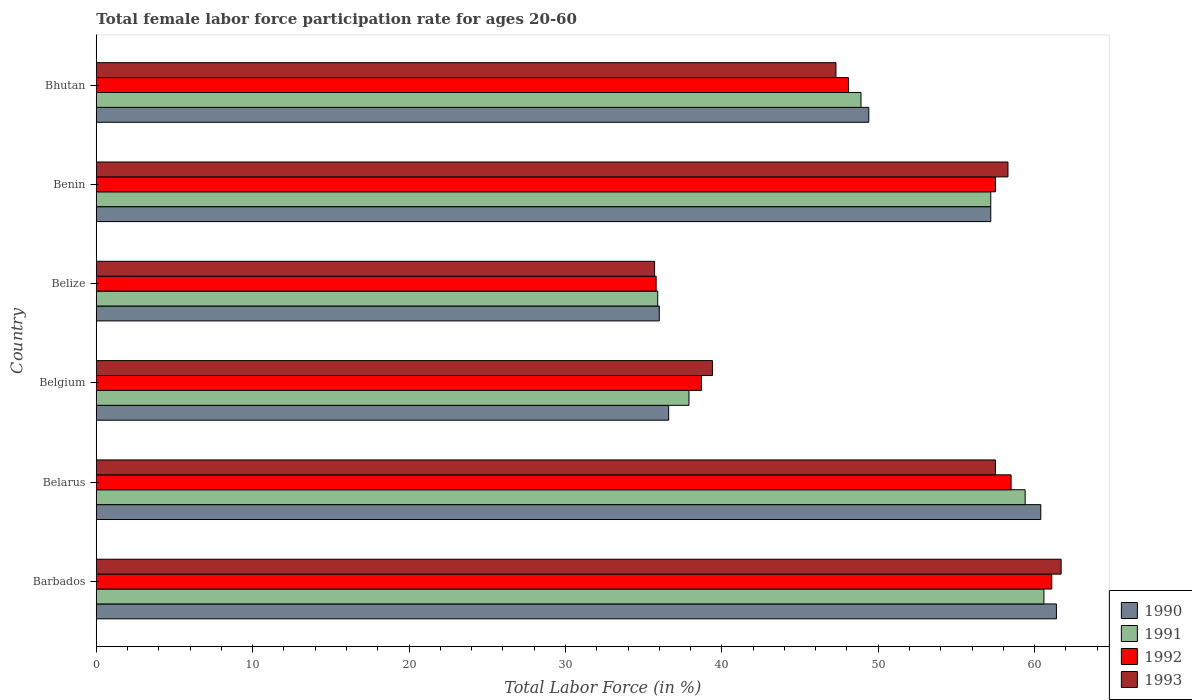How many groups of bars are there?
Keep it short and to the point. 6. Are the number of bars per tick equal to the number of legend labels?
Your answer should be very brief. Yes. Are the number of bars on each tick of the Y-axis equal?
Give a very brief answer. Yes. What is the female labor force participation rate in 1991 in Belarus?
Provide a succinct answer. 59.4. Across all countries, what is the maximum female labor force participation rate in 1992?
Provide a succinct answer. 61.1. Across all countries, what is the minimum female labor force participation rate in 1992?
Offer a terse response. 35.8. In which country was the female labor force participation rate in 1991 maximum?
Your answer should be compact. Barbados. In which country was the female labor force participation rate in 1993 minimum?
Your response must be concise. Belize. What is the total female labor force participation rate in 1991 in the graph?
Make the answer very short. 299.9. What is the difference between the female labor force participation rate in 1991 in Belgium and that in Belize?
Your answer should be very brief. 2. What is the difference between the female labor force participation rate in 1990 in Bhutan and the female labor force participation rate in 1991 in Barbados?
Make the answer very short. -11.2. What is the average female labor force participation rate in 1992 per country?
Provide a succinct answer. 49.95. What is the difference between the female labor force participation rate in 1992 and female labor force participation rate in 1991 in Benin?
Provide a succinct answer. 0.3. In how many countries, is the female labor force participation rate in 1990 greater than 56 %?
Ensure brevity in your answer.  3. What is the ratio of the female labor force participation rate in 1991 in Barbados to that in Belgium?
Your response must be concise. 1.6. Is the female labor force participation rate in 1991 in Barbados less than that in Belize?
Offer a terse response. No. Is the difference between the female labor force participation rate in 1992 in Belize and Bhutan greater than the difference between the female labor force participation rate in 1991 in Belize and Bhutan?
Ensure brevity in your answer.  Yes. What is the difference between the highest and the second highest female labor force participation rate in 1991?
Keep it short and to the point. 1.2. What is the difference between the highest and the lowest female labor force participation rate in 1993?
Offer a terse response. 26. Is the sum of the female labor force participation rate in 1992 in Belize and Benin greater than the maximum female labor force participation rate in 1990 across all countries?
Offer a terse response. Yes. Is it the case that in every country, the sum of the female labor force participation rate in 1991 and female labor force participation rate in 1992 is greater than the sum of female labor force participation rate in 1990 and female labor force participation rate in 1993?
Give a very brief answer. No. What does the 3rd bar from the bottom in Belgium represents?
Offer a terse response. 1992. Are the values on the major ticks of X-axis written in scientific E-notation?
Ensure brevity in your answer.  No. Where does the legend appear in the graph?
Provide a succinct answer. Bottom right. How many legend labels are there?
Keep it short and to the point. 4. How are the legend labels stacked?
Offer a terse response. Vertical. What is the title of the graph?
Ensure brevity in your answer.  Total female labor force participation rate for ages 20-60. Does "1965" appear as one of the legend labels in the graph?
Make the answer very short. No. What is the label or title of the Y-axis?
Offer a terse response. Country. What is the Total Labor Force (in %) in 1990 in Barbados?
Your answer should be compact. 61.4. What is the Total Labor Force (in %) of 1991 in Barbados?
Provide a succinct answer. 60.6. What is the Total Labor Force (in %) in 1992 in Barbados?
Keep it short and to the point. 61.1. What is the Total Labor Force (in %) of 1993 in Barbados?
Give a very brief answer. 61.7. What is the Total Labor Force (in %) in 1990 in Belarus?
Provide a succinct answer. 60.4. What is the Total Labor Force (in %) in 1991 in Belarus?
Your answer should be compact. 59.4. What is the Total Labor Force (in %) of 1992 in Belarus?
Keep it short and to the point. 58.5. What is the Total Labor Force (in %) of 1993 in Belarus?
Give a very brief answer. 57.5. What is the Total Labor Force (in %) in 1990 in Belgium?
Give a very brief answer. 36.6. What is the Total Labor Force (in %) in 1991 in Belgium?
Keep it short and to the point. 37.9. What is the Total Labor Force (in %) in 1992 in Belgium?
Make the answer very short. 38.7. What is the Total Labor Force (in %) in 1993 in Belgium?
Ensure brevity in your answer.  39.4. What is the Total Labor Force (in %) in 1991 in Belize?
Give a very brief answer. 35.9. What is the Total Labor Force (in %) in 1992 in Belize?
Make the answer very short. 35.8. What is the Total Labor Force (in %) in 1993 in Belize?
Offer a terse response. 35.7. What is the Total Labor Force (in %) in 1990 in Benin?
Offer a very short reply. 57.2. What is the Total Labor Force (in %) in 1991 in Benin?
Your answer should be very brief. 57.2. What is the Total Labor Force (in %) in 1992 in Benin?
Keep it short and to the point. 57.5. What is the Total Labor Force (in %) in 1993 in Benin?
Provide a succinct answer. 58.3. What is the Total Labor Force (in %) in 1990 in Bhutan?
Provide a succinct answer. 49.4. What is the Total Labor Force (in %) in 1991 in Bhutan?
Ensure brevity in your answer.  48.9. What is the Total Labor Force (in %) in 1992 in Bhutan?
Your response must be concise. 48.1. What is the Total Labor Force (in %) in 1993 in Bhutan?
Keep it short and to the point. 47.3. Across all countries, what is the maximum Total Labor Force (in %) in 1990?
Make the answer very short. 61.4. Across all countries, what is the maximum Total Labor Force (in %) of 1991?
Ensure brevity in your answer.  60.6. Across all countries, what is the maximum Total Labor Force (in %) of 1992?
Your response must be concise. 61.1. Across all countries, what is the maximum Total Labor Force (in %) in 1993?
Keep it short and to the point. 61.7. Across all countries, what is the minimum Total Labor Force (in %) of 1990?
Give a very brief answer. 36. Across all countries, what is the minimum Total Labor Force (in %) of 1991?
Give a very brief answer. 35.9. Across all countries, what is the minimum Total Labor Force (in %) of 1992?
Keep it short and to the point. 35.8. Across all countries, what is the minimum Total Labor Force (in %) in 1993?
Your answer should be compact. 35.7. What is the total Total Labor Force (in %) of 1990 in the graph?
Offer a very short reply. 301. What is the total Total Labor Force (in %) in 1991 in the graph?
Your answer should be compact. 299.9. What is the total Total Labor Force (in %) of 1992 in the graph?
Keep it short and to the point. 299.7. What is the total Total Labor Force (in %) of 1993 in the graph?
Give a very brief answer. 299.9. What is the difference between the Total Labor Force (in %) of 1990 in Barbados and that in Belarus?
Make the answer very short. 1. What is the difference between the Total Labor Force (in %) of 1992 in Barbados and that in Belarus?
Make the answer very short. 2.6. What is the difference between the Total Labor Force (in %) in 1990 in Barbados and that in Belgium?
Your answer should be compact. 24.8. What is the difference between the Total Labor Force (in %) of 1991 in Barbados and that in Belgium?
Keep it short and to the point. 22.7. What is the difference between the Total Labor Force (in %) in 1992 in Barbados and that in Belgium?
Offer a terse response. 22.4. What is the difference between the Total Labor Force (in %) of 1993 in Barbados and that in Belgium?
Keep it short and to the point. 22.3. What is the difference between the Total Labor Force (in %) of 1990 in Barbados and that in Belize?
Keep it short and to the point. 25.4. What is the difference between the Total Labor Force (in %) in 1991 in Barbados and that in Belize?
Provide a succinct answer. 24.7. What is the difference between the Total Labor Force (in %) of 1992 in Barbados and that in Belize?
Give a very brief answer. 25.3. What is the difference between the Total Labor Force (in %) of 1990 in Barbados and that in Benin?
Your answer should be very brief. 4.2. What is the difference between the Total Labor Force (in %) in 1991 in Barbados and that in Benin?
Your answer should be compact. 3.4. What is the difference between the Total Labor Force (in %) in 1992 in Barbados and that in Benin?
Ensure brevity in your answer.  3.6. What is the difference between the Total Labor Force (in %) of 1993 in Barbados and that in Benin?
Your answer should be compact. 3.4. What is the difference between the Total Labor Force (in %) of 1990 in Barbados and that in Bhutan?
Your answer should be very brief. 12. What is the difference between the Total Labor Force (in %) of 1991 in Barbados and that in Bhutan?
Your answer should be very brief. 11.7. What is the difference between the Total Labor Force (in %) in 1993 in Barbados and that in Bhutan?
Offer a very short reply. 14.4. What is the difference between the Total Labor Force (in %) in 1990 in Belarus and that in Belgium?
Your answer should be very brief. 23.8. What is the difference between the Total Labor Force (in %) in 1991 in Belarus and that in Belgium?
Keep it short and to the point. 21.5. What is the difference between the Total Labor Force (in %) in 1992 in Belarus and that in Belgium?
Your response must be concise. 19.8. What is the difference between the Total Labor Force (in %) in 1993 in Belarus and that in Belgium?
Make the answer very short. 18.1. What is the difference between the Total Labor Force (in %) in 1990 in Belarus and that in Belize?
Your answer should be very brief. 24.4. What is the difference between the Total Labor Force (in %) of 1992 in Belarus and that in Belize?
Make the answer very short. 22.7. What is the difference between the Total Labor Force (in %) in 1993 in Belarus and that in Belize?
Your response must be concise. 21.8. What is the difference between the Total Labor Force (in %) of 1990 in Belarus and that in Benin?
Your answer should be very brief. 3.2. What is the difference between the Total Labor Force (in %) of 1991 in Belarus and that in Benin?
Provide a succinct answer. 2.2. What is the difference between the Total Labor Force (in %) in 1992 in Belarus and that in Benin?
Make the answer very short. 1. What is the difference between the Total Labor Force (in %) in 1990 in Belarus and that in Bhutan?
Provide a short and direct response. 11. What is the difference between the Total Labor Force (in %) in 1991 in Belarus and that in Bhutan?
Give a very brief answer. 10.5. What is the difference between the Total Labor Force (in %) in 1992 in Belarus and that in Bhutan?
Offer a very short reply. 10.4. What is the difference between the Total Labor Force (in %) of 1992 in Belgium and that in Belize?
Ensure brevity in your answer.  2.9. What is the difference between the Total Labor Force (in %) of 1993 in Belgium and that in Belize?
Provide a short and direct response. 3.7. What is the difference between the Total Labor Force (in %) in 1990 in Belgium and that in Benin?
Keep it short and to the point. -20.6. What is the difference between the Total Labor Force (in %) of 1991 in Belgium and that in Benin?
Provide a short and direct response. -19.3. What is the difference between the Total Labor Force (in %) in 1992 in Belgium and that in Benin?
Offer a terse response. -18.8. What is the difference between the Total Labor Force (in %) of 1993 in Belgium and that in Benin?
Your answer should be compact. -18.9. What is the difference between the Total Labor Force (in %) in 1992 in Belgium and that in Bhutan?
Ensure brevity in your answer.  -9.4. What is the difference between the Total Labor Force (in %) of 1990 in Belize and that in Benin?
Your response must be concise. -21.2. What is the difference between the Total Labor Force (in %) in 1991 in Belize and that in Benin?
Your answer should be compact. -21.3. What is the difference between the Total Labor Force (in %) in 1992 in Belize and that in Benin?
Your response must be concise. -21.7. What is the difference between the Total Labor Force (in %) of 1993 in Belize and that in Benin?
Your answer should be very brief. -22.6. What is the difference between the Total Labor Force (in %) of 1991 in Belize and that in Bhutan?
Your answer should be compact. -13. What is the difference between the Total Labor Force (in %) in 1992 in Belize and that in Bhutan?
Your answer should be very brief. -12.3. What is the difference between the Total Labor Force (in %) of 1990 in Barbados and the Total Labor Force (in %) of 1991 in Belarus?
Your answer should be compact. 2. What is the difference between the Total Labor Force (in %) of 1990 in Barbados and the Total Labor Force (in %) of 1992 in Belarus?
Provide a short and direct response. 2.9. What is the difference between the Total Labor Force (in %) in 1992 in Barbados and the Total Labor Force (in %) in 1993 in Belarus?
Keep it short and to the point. 3.6. What is the difference between the Total Labor Force (in %) of 1990 in Barbados and the Total Labor Force (in %) of 1991 in Belgium?
Offer a terse response. 23.5. What is the difference between the Total Labor Force (in %) of 1990 in Barbados and the Total Labor Force (in %) of 1992 in Belgium?
Make the answer very short. 22.7. What is the difference between the Total Labor Force (in %) of 1991 in Barbados and the Total Labor Force (in %) of 1992 in Belgium?
Provide a succinct answer. 21.9. What is the difference between the Total Labor Force (in %) of 1991 in Barbados and the Total Labor Force (in %) of 1993 in Belgium?
Ensure brevity in your answer.  21.2. What is the difference between the Total Labor Force (in %) of 1992 in Barbados and the Total Labor Force (in %) of 1993 in Belgium?
Give a very brief answer. 21.7. What is the difference between the Total Labor Force (in %) in 1990 in Barbados and the Total Labor Force (in %) in 1991 in Belize?
Your answer should be very brief. 25.5. What is the difference between the Total Labor Force (in %) of 1990 in Barbados and the Total Labor Force (in %) of 1992 in Belize?
Offer a terse response. 25.6. What is the difference between the Total Labor Force (in %) in 1990 in Barbados and the Total Labor Force (in %) in 1993 in Belize?
Your answer should be compact. 25.7. What is the difference between the Total Labor Force (in %) of 1991 in Barbados and the Total Labor Force (in %) of 1992 in Belize?
Ensure brevity in your answer.  24.8. What is the difference between the Total Labor Force (in %) of 1991 in Barbados and the Total Labor Force (in %) of 1993 in Belize?
Your response must be concise. 24.9. What is the difference between the Total Labor Force (in %) of 1992 in Barbados and the Total Labor Force (in %) of 1993 in Belize?
Make the answer very short. 25.4. What is the difference between the Total Labor Force (in %) in 1990 in Barbados and the Total Labor Force (in %) in 1991 in Benin?
Keep it short and to the point. 4.2. What is the difference between the Total Labor Force (in %) of 1990 in Barbados and the Total Labor Force (in %) of 1993 in Benin?
Provide a succinct answer. 3.1. What is the difference between the Total Labor Force (in %) of 1991 in Barbados and the Total Labor Force (in %) of 1993 in Benin?
Ensure brevity in your answer.  2.3. What is the difference between the Total Labor Force (in %) of 1992 in Barbados and the Total Labor Force (in %) of 1993 in Benin?
Ensure brevity in your answer.  2.8. What is the difference between the Total Labor Force (in %) of 1990 in Barbados and the Total Labor Force (in %) of 1992 in Bhutan?
Give a very brief answer. 13.3. What is the difference between the Total Labor Force (in %) of 1990 in Barbados and the Total Labor Force (in %) of 1993 in Bhutan?
Offer a terse response. 14.1. What is the difference between the Total Labor Force (in %) in 1991 in Barbados and the Total Labor Force (in %) in 1992 in Bhutan?
Keep it short and to the point. 12.5. What is the difference between the Total Labor Force (in %) in 1992 in Barbados and the Total Labor Force (in %) in 1993 in Bhutan?
Provide a short and direct response. 13.8. What is the difference between the Total Labor Force (in %) of 1990 in Belarus and the Total Labor Force (in %) of 1992 in Belgium?
Give a very brief answer. 21.7. What is the difference between the Total Labor Force (in %) in 1991 in Belarus and the Total Labor Force (in %) in 1992 in Belgium?
Give a very brief answer. 20.7. What is the difference between the Total Labor Force (in %) in 1991 in Belarus and the Total Labor Force (in %) in 1993 in Belgium?
Provide a short and direct response. 20. What is the difference between the Total Labor Force (in %) in 1990 in Belarus and the Total Labor Force (in %) in 1991 in Belize?
Provide a succinct answer. 24.5. What is the difference between the Total Labor Force (in %) of 1990 in Belarus and the Total Labor Force (in %) of 1992 in Belize?
Make the answer very short. 24.6. What is the difference between the Total Labor Force (in %) in 1990 in Belarus and the Total Labor Force (in %) in 1993 in Belize?
Your response must be concise. 24.7. What is the difference between the Total Labor Force (in %) in 1991 in Belarus and the Total Labor Force (in %) in 1992 in Belize?
Make the answer very short. 23.6. What is the difference between the Total Labor Force (in %) of 1991 in Belarus and the Total Labor Force (in %) of 1993 in Belize?
Your answer should be very brief. 23.7. What is the difference between the Total Labor Force (in %) of 1992 in Belarus and the Total Labor Force (in %) of 1993 in Belize?
Offer a terse response. 22.8. What is the difference between the Total Labor Force (in %) in 1990 in Belarus and the Total Labor Force (in %) in 1991 in Benin?
Keep it short and to the point. 3.2. What is the difference between the Total Labor Force (in %) in 1991 in Belarus and the Total Labor Force (in %) in 1992 in Benin?
Your answer should be very brief. 1.9. What is the difference between the Total Labor Force (in %) in 1992 in Belarus and the Total Labor Force (in %) in 1993 in Benin?
Make the answer very short. 0.2. What is the difference between the Total Labor Force (in %) of 1990 in Belarus and the Total Labor Force (in %) of 1991 in Bhutan?
Keep it short and to the point. 11.5. What is the difference between the Total Labor Force (in %) of 1991 in Belarus and the Total Labor Force (in %) of 1992 in Bhutan?
Ensure brevity in your answer.  11.3. What is the difference between the Total Labor Force (in %) of 1991 in Belarus and the Total Labor Force (in %) of 1993 in Bhutan?
Your response must be concise. 12.1. What is the difference between the Total Labor Force (in %) in 1990 in Belgium and the Total Labor Force (in %) in 1993 in Belize?
Provide a succinct answer. 0.9. What is the difference between the Total Labor Force (in %) of 1991 in Belgium and the Total Labor Force (in %) of 1993 in Belize?
Make the answer very short. 2.2. What is the difference between the Total Labor Force (in %) in 1990 in Belgium and the Total Labor Force (in %) in 1991 in Benin?
Offer a terse response. -20.6. What is the difference between the Total Labor Force (in %) in 1990 in Belgium and the Total Labor Force (in %) in 1992 in Benin?
Offer a very short reply. -20.9. What is the difference between the Total Labor Force (in %) of 1990 in Belgium and the Total Labor Force (in %) of 1993 in Benin?
Ensure brevity in your answer.  -21.7. What is the difference between the Total Labor Force (in %) in 1991 in Belgium and the Total Labor Force (in %) in 1992 in Benin?
Give a very brief answer. -19.6. What is the difference between the Total Labor Force (in %) in 1991 in Belgium and the Total Labor Force (in %) in 1993 in Benin?
Provide a short and direct response. -20.4. What is the difference between the Total Labor Force (in %) in 1992 in Belgium and the Total Labor Force (in %) in 1993 in Benin?
Provide a short and direct response. -19.6. What is the difference between the Total Labor Force (in %) in 1990 in Belgium and the Total Labor Force (in %) in 1991 in Bhutan?
Offer a terse response. -12.3. What is the difference between the Total Labor Force (in %) in 1990 in Belgium and the Total Labor Force (in %) in 1992 in Bhutan?
Your response must be concise. -11.5. What is the difference between the Total Labor Force (in %) of 1991 in Belgium and the Total Labor Force (in %) of 1992 in Bhutan?
Your answer should be compact. -10.2. What is the difference between the Total Labor Force (in %) of 1991 in Belgium and the Total Labor Force (in %) of 1993 in Bhutan?
Offer a terse response. -9.4. What is the difference between the Total Labor Force (in %) of 1992 in Belgium and the Total Labor Force (in %) of 1993 in Bhutan?
Make the answer very short. -8.6. What is the difference between the Total Labor Force (in %) in 1990 in Belize and the Total Labor Force (in %) in 1991 in Benin?
Make the answer very short. -21.2. What is the difference between the Total Labor Force (in %) in 1990 in Belize and the Total Labor Force (in %) in 1992 in Benin?
Your response must be concise. -21.5. What is the difference between the Total Labor Force (in %) of 1990 in Belize and the Total Labor Force (in %) of 1993 in Benin?
Offer a very short reply. -22.3. What is the difference between the Total Labor Force (in %) of 1991 in Belize and the Total Labor Force (in %) of 1992 in Benin?
Give a very brief answer. -21.6. What is the difference between the Total Labor Force (in %) of 1991 in Belize and the Total Labor Force (in %) of 1993 in Benin?
Offer a very short reply. -22.4. What is the difference between the Total Labor Force (in %) in 1992 in Belize and the Total Labor Force (in %) in 1993 in Benin?
Ensure brevity in your answer.  -22.5. What is the difference between the Total Labor Force (in %) of 1990 in Belize and the Total Labor Force (in %) of 1991 in Bhutan?
Offer a very short reply. -12.9. What is the difference between the Total Labor Force (in %) in 1990 in Belize and the Total Labor Force (in %) in 1992 in Bhutan?
Your answer should be compact. -12.1. What is the difference between the Total Labor Force (in %) in 1991 in Belize and the Total Labor Force (in %) in 1993 in Bhutan?
Give a very brief answer. -11.4. What is the difference between the Total Labor Force (in %) of 1992 in Belize and the Total Labor Force (in %) of 1993 in Bhutan?
Provide a short and direct response. -11.5. What is the difference between the Total Labor Force (in %) in 1990 in Benin and the Total Labor Force (in %) in 1991 in Bhutan?
Your answer should be very brief. 8.3. What is the difference between the Total Labor Force (in %) of 1990 in Benin and the Total Labor Force (in %) of 1992 in Bhutan?
Your response must be concise. 9.1. What is the difference between the Total Labor Force (in %) of 1991 in Benin and the Total Labor Force (in %) of 1992 in Bhutan?
Offer a terse response. 9.1. What is the difference between the Total Labor Force (in %) in 1991 in Benin and the Total Labor Force (in %) in 1993 in Bhutan?
Make the answer very short. 9.9. What is the difference between the Total Labor Force (in %) in 1992 in Benin and the Total Labor Force (in %) in 1993 in Bhutan?
Your answer should be compact. 10.2. What is the average Total Labor Force (in %) of 1990 per country?
Ensure brevity in your answer.  50.17. What is the average Total Labor Force (in %) of 1991 per country?
Offer a very short reply. 49.98. What is the average Total Labor Force (in %) of 1992 per country?
Your answer should be very brief. 49.95. What is the average Total Labor Force (in %) of 1993 per country?
Keep it short and to the point. 49.98. What is the difference between the Total Labor Force (in %) of 1990 and Total Labor Force (in %) of 1991 in Barbados?
Your answer should be very brief. 0.8. What is the difference between the Total Labor Force (in %) in 1990 and Total Labor Force (in %) in 1993 in Barbados?
Offer a terse response. -0.3. What is the difference between the Total Labor Force (in %) in 1991 and Total Labor Force (in %) in 1993 in Barbados?
Give a very brief answer. -1.1. What is the difference between the Total Labor Force (in %) in 1992 and Total Labor Force (in %) in 1993 in Barbados?
Provide a succinct answer. -0.6. What is the difference between the Total Labor Force (in %) in 1990 and Total Labor Force (in %) in 1992 in Belarus?
Offer a very short reply. 1.9. What is the difference between the Total Labor Force (in %) of 1991 and Total Labor Force (in %) of 1992 in Belarus?
Keep it short and to the point. 0.9. What is the difference between the Total Labor Force (in %) of 1991 and Total Labor Force (in %) of 1993 in Belarus?
Offer a terse response. 1.9. What is the difference between the Total Labor Force (in %) in 1991 and Total Labor Force (in %) in 1993 in Belgium?
Offer a very short reply. -1.5. What is the difference between the Total Labor Force (in %) of 1992 and Total Labor Force (in %) of 1993 in Belgium?
Your response must be concise. -0.7. What is the difference between the Total Labor Force (in %) of 1990 and Total Labor Force (in %) of 1992 in Belize?
Offer a very short reply. 0.2. What is the difference between the Total Labor Force (in %) in 1992 and Total Labor Force (in %) in 1993 in Belize?
Your answer should be very brief. 0.1. What is the difference between the Total Labor Force (in %) in 1990 and Total Labor Force (in %) in 1991 in Benin?
Your answer should be very brief. 0. What is the difference between the Total Labor Force (in %) in 1990 and Total Labor Force (in %) in 1993 in Benin?
Your answer should be very brief. -1.1. What is the difference between the Total Labor Force (in %) in 1991 and Total Labor Force (in %) in 1993 in Benin?
Provide a short and direct response. -1.1. What is the difference between the Total Labor Force (in %) of 1990 and Total Labor Force (in %) of 1991 in Bhutan?
Ensure brevity in your answer.  0.5. What is the difference between the Total Labor Force (in %) of 1990 and Total Labor Force (in %) of 1992 in Bhutan?
Your answer should be very brief. 1.3. What is the difference between the Total Labor Force (in %) of 1990 and Total Labor Force (in %) of 1993 in Bhutan?
Your answer should be compact. 2.1. What is the difference between the Total Labor Force (in %) in 1991 and Total Labor Force (in %) in 1993 in Bhutan?
Offer a terse response. 1.6. What is the ratio of the Total Labor Force (in %) of 1990 in Barbados to that in Belarus?
Provide a short and direct response. 1.02. What is the ratio of the Total Labor Force (in %) in 1991 in Barbados to that in Belarus?
Provide a succinct answer. 1.02. What is the ratio of the Total Labor Force (in %) in 1992 in Barbados to that in Belarus?
Keep it short and to the point. 1.04. What is the ratio of the Total Labor Force (in %) of 1993 in Barbados to that in Belarus?
Ensure brevity in your answer.  1.07. What is the ratio of the Total Labor Force (in %) in 1990 in Barbados to that in Belgium?
Offer a very short reply. 1.68. What is the ratio of the Total Labor Force (in %) of 1991 in Barbados to that in Belgium?
Your answer should be very brief. 1.6. What is the ratio of the Total Labor Force (in %) in 1992 in Barbados to that in Belgium?
Your answer should be very brief. 1.58. What is the ratio of the Total Labor Force (in %) in 1993 in Barbados to that in Belgium?
Your response must be concise. 1.57. What is the ratio of the Total Labor Force (in %) in 1990 in Barbados to that in Belize?
Keep it short and to the point. 1.71. What is the ratio of the Total Labor Force (in %) in 1991 in Barbados to that in Belize?
Give a very brief answer. 1.69. What is the ratio of the Total Labor Force (in %) in 1992 in Barbados to that in Belize?
Your answer should be very brief. 1.71. What is the ratio of the Total Labor Force (in %) of 1993 in Barbados to that in Belize?
Provide a succinct answer. 1.73. What is the ratio of the Total Labor Force (in %) of 1990 in Barbados to that in Benin?
Offer a very short reply. 1.07. What is the ratio of the Total Labor Force (in %) in 1991 in Barbados to that in Benin?
Make the answer very short. 1.06. What is the ratio of the Total Labor Force (in %) in 1992 in Barbados to that in Benin?
Your answer should be compact. 1.06. What is the ratio of the Total Labor Force (in %) in 1993 in Barbados to that in Benin?
Your answer should be very brief. 1.06. What is the ratio of the Total Labor Force (in %) of 1990 in Barbados to that in Bhutan?
Ensure brevity in your answer.  1.24. What is the ratio of the Total Labor Force (in %) in 1991 in Barbados to that in Bhutan?
Your response must be concise. 1.24. What is the ratio of the Total Labor Force (in %) in 1992 in Barbados to that in Bhutan?
Make the answer very short. 1.27. What is the ratio of the Total Labor Force (in %) of 1993 in Barbados to that in Bhutan?
Provide a short and direct response. 1.3. What is the ratio of the Total Labor Force (in %) in 1990 in Belarus to that in Belgium?
Keep it short and to the point. 1.65. What is the ratio of the Total Labor Force (in %) in 1991 in Belarus to that in Belgium?
Ensure brevity in your answer.  1.57. What is the ratio of the Total Labor Force (in %) in 1992 in Belarus to that in Belgium?
Your answer should be very brief. 1.51. What is the ratio of the Total Labor Force (in %) of 1993 in Belarus to that in Belgium?
Ensure brevity in your answer.  1.46. What is the ratio of the Total Labor Force (in %) of 1990 in Belarus to that in Belize?
Make the answer very short. 1.68. What is the ratio of the Total Labor Force (in %) of 1991 in Belarus to that in Belize?
Ensure brevity in your answer.  1.65. What is the ratio of the Total Labor Force (in %) in 1992 in Belarus to that in Belize?
Your answer should be very brief. 1.63. What is the ratio of the Total Labor Force (in %) of 1993 in Belarus to that in Belize?
Ensure brevity in your answer.  1.61. What is the ratio of the Total Labor Force (in %) of 1990 in Belarus to that in Benin?
Give a very brief answer. 1.06. What is the ratio of the Total Labor Force (in %) in 1992 in Belarus to that in Benin?
Offer a terse response. 1.02. What is the ratio of the Total Labor Force (in %) of 1993 in Belarus to that in Benin?
Provide a short and direct response. 0.99. What is the ratio of the Total Labor Force (in %) in 1990 in Belarus to that in Bhutan?
Provide a short and direct response. 1.22. What is the ratio of the Total Labor Force (in %) of 1991 in Belarus to that in Bhutan?
Give a very brief answer. 1.21. What is the ratio of the Total Labor Force (in %) in 1992 in Belarus to that in Bhutan?
Your answer should be very brief. 1.22. What is the ratio of the Total Labor Force (in %) of 1993 in Belarus to that in Bhutan?
Your answer should be very brief. 1.22. What is the ratio of the Total Labor Force (in %) of 1990 in Belgium to that in Belize?
Your answer should be compact. 1.02. What is the ratio of the Total Labor Force (in %) in 1991 in Belgium to that in Belize?
Your answer should be compact. 1.06. What is the ratio of the Total Labor Force (in %) in 1992 in Belgium to that in Belize?
Your answer should be very brief. 1.08. What is the ratio of the Total Labor Force (in %) in 1993 in Belgium to that in Belize?
Keep it short and to the point. 1.1. What is the ratio of the Total Labor Force (in %) in 1990 in Belgium to that in Benin?
Your answer should be compact. 0.64. What is the ratio of the Total Labor Force (in %) of 1991 in Belgium to that in Benin?
Give a very brief answer. 0.66. What is the ratio of the Total Labor Force (in %) in 1992 in Belgium to that in Benin?
Your answer should be very brief. 0.67. What is the ratio of the Total Labor Force (in %) in 1993 in Belgium to that in Benin?
Provide a succinct answer. 0.68. What is the ratio of the Total Labor Force (in %) of 1990 in Belgium to that in Bhutan?
Keep it short and to the point. 0.74. What is the ratio of the Total Labor Force (in %) of 1991 in Belgium to that in Bhutan?
Your answer should be very brief. 0.78. What is the ratio of the Total Labor Force (in %) of 1992 in Belgium to that in Bhutan?
Keep it short and to the point. 0.8. What is the ratio of the Total Labor Force (in %) in 1993 in Belgium to that in Bhutan?
Offer a very short reply. 0.83. What is the ratio of the Total Labor Force (in %) in 1990 in Belize to that in Benin?
Give a very brief answer. 0.63. What is the ratio of the Total Labor Force (in %) of 1991 in Belize to that in Benin?
Your response must be concise. 0.63. What is the ratio of the Total Labor Force (in %) in 1992 in Belize to that in Benin?
Provide a succinct answer. 0.62. What is the ratio of the Total Labor Force (in %) in 1993 in Belize to that in Benin?
Ensure brevity in your answer.  0.61. What is the ratio of the Total Labor Force (in %) in 1990 in Belize to that in Bhutan?
Your response must be concise. 0.73. What is the ratio of the Total Labor Force (in %) in 1991 in Belize to that in Bhutan?
Your answer should be compact. 0.73. What is the ratio of the Total Labor Force (in %) in 1992 in Belize to that in Bhutan?
Your answer should be very brief. 0.74. What is the ratio of the Total Labor Force (in %) of 1993 in Belize to that in Bhutan?
Your answer should be very brief. 0.75. What is the ratio of the Total Labor Force (in %) in 1990 in Benin to that in Bhutan?
Provide a short and direct response. 1.16. What is the ratio of the Total Labor Force (in %) of 1991 in Benin to that in Bhutan?
Provide a succinct answer. 1.17. What is the ratio of the Total Labor Force (in %) of 1992 in Benin to that in Bhutan?
Provide a succinct answer. 1.2. What is the ratio of the Total Labor Force (in %) of 1993 in Benin to that in Bhutan?
Ensure brevity in your answer.  1.23. What is the difference between the highest and the second highest Total Labor Force (in %) in 1990?
Provide a succinct answer. 1. What is the difference between the highest and the second highest Total Labor Force (in %) of 1991?
Keep it short and to the point. 1.2. What is the difference between the highest and the second highest Total Labor Force (in %) in 1992?
Your answer should be very brief. 2.6. What is the difference between the highest and the second highest Total Labor Force (in %) in 1993?
Ensure brevity in your answer.  3.4. What is the difference between the highest and the lowest Total Labor Force (in %) of 1990?
Ensure brevity in your answer.  25.4. What is the difference between the highest and the lowest Total Labor Force (in %) in 1991?
Offer a terse response. 24.7. What is the difference between the highest and the lowest Total Labor Force (in %) in 1992?
Make the answer very short. 25.3. What is the difference between the highest and the lowest Total Labor Force (in %) of 1993?
Ensure brevity in your answer.  26. 